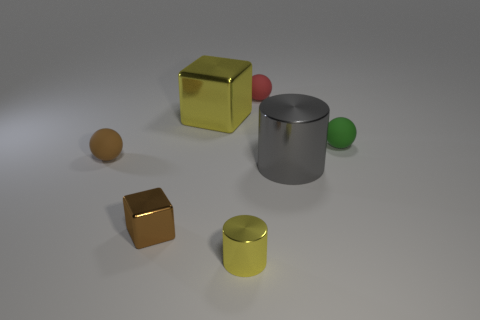Is the number of large yellow shiny things greater than the number of tiny blue objects?
Your answer should be compact. Yes. Is there anything else that has the same color as the tiny cylinder?
Keep it short and to the point. Yes. What size is the gray thing that is the same material as the small block?
Provide a succinct answer. Large. What is the material of the large block?
Offer a terse response. Metal. How many cyan blocks are the same size as the red rubber thing?
Keep it short and to the point. 0. What is the shape of the big object that is the same color as the tiny shiny cylinder?
Ensure brevity in your answer.  Cube. Is there a tiny red thing that has the same shape as the tiny green matte object?
Your response must be concise. Yes. There is a cylinder that is the same size as the green ball; what color is it?
Your response must be concise. Yellow. There is a small rubber object that is right of the cylinder behind the brown metal cube; what color is it?
Your answer should be very brief. Green. Does the small sphere behind the small green matte sphere have the same color as the tiny cube?
Keep it short and to the point. No. 